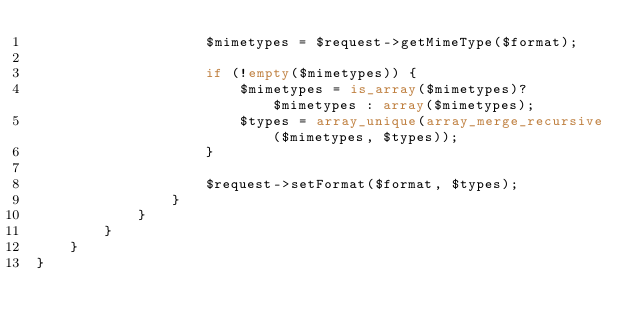<code> <loc_0><loc_0><loc_500><loc_500><_PHP_>                    $mimetypes = $request->getMimeType($format);

                    if (!empty($mimetypes)) {
                        $mimetypes = is_array($mimetypes)? $mimetypes : array($mimetypes);
                        $types = array_unique(array_merge_recursive($mimetypes, $types));
                    }

                    $request->setFormat($format, $types);
                }
            }
        }
    }
}
</code> 